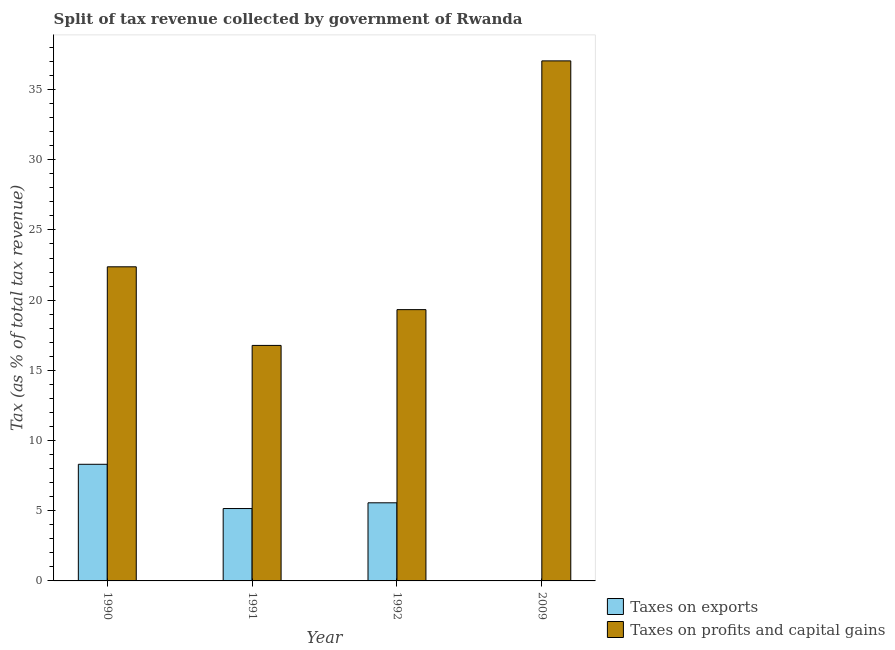How many different coloured bars are there?
Your response must be concise. 2. Are the number of bars per tick equal to the number of legend labels?
Ensure brevity in your answer.  Yes. Are the number of bars on each tick of the X-axis equal?
Your answer should be very brief. Yes. How many bars are there on the 3rd tick from the left?
Give a very brief answer. 2. How many bars are there on the 2nd tick from the right?
Keep it short and to the point. 2. In how many cases, is the number of bars for a given year not equal to the number of legend labels?
Your answer should be compact. 0. What is the percentage of revenue obtained from taxes on exports in 2009?
Ensure brevity in your answer.  0. Across all years, what is the maximum percentage of revenue obtained from taxes on profits and capital gains?
Your answer should be very brief. 37.04. Across all years, what is the minimum percentage of revenue obtained from taxes on exports?
Make the answer very short. 0. In which year was the percentage of revenue obtained from taxes on exports maximum?
Your response must be concise. 1990. What is the total percentage of revenue obtained from taxes on exports in the graph?
Your answer should be very brief. 19.03. What is the difference between the percentage of revenue obtained from taxes on exports in 1991 and that in 2009?
Your answer should be very brief. 5.15. What is the difference between the percentage of revenue obtained from taxes on exports in 1990 and the percentage of revenue obtained from taxes on profits and capital gains in 2009?
Keep it short and to the point. 8.3. What is the average percentage of revenue obtained from taxes on exports per year?
Provide a short and direct response. 4.76. In the year 1990, what is the difference between the percentage of revenue obtained from taxes on profits and capital gains and percentage of revenue obtained from taxes on exports?
Provide a short and direct response. 0. In how many years, is the percentage of revenue obtained from taxes on profits and capital gains greater than 30 %?
Offer a very short reply. 1. What is the ratio of the percentage of revenue obtained from taxes on exports in 1990 to that in 1992?
Provide a succinct answer. 1.49. What is the difference between the highest and the second highest percentage of revenue obtained from taxes on exports?
Your response must be concise. 2.74. What is the difference between the highest and the lowest percentage of revenue obtained from taxes on profits and capital gains?
Provide a succinct answer. 20.27. Is the sum of the percentage of revenue obtained from taxes on exports in 1990 and 2009 greater than the maximum percentage of revenue obtained from taxes on profits and capital gains across all years?
Your answer should be compact. Yes. What does the 1st bar from the left in 1990 represents?
Your answer should be compact. Taxes on exports. What does the 1st bar from the right in 2009 represents?
Offer a terse response. Taxes on profits and capital gains. How many bars are there?
Ensure brevity in your answer.  8. Are all the bars in the graph horizontal?
Your answer should be compact. No. How many years are there in the graph?
Give a very brief answer. 4. What is the difference between two consecutive major ticks on the Y-axis?
Ensure brevity in your answer.  5. Are the values on the major ticks of Y-axis written in scientific E-notation?
Make the answer very short. No. Does the graph contain grids?
Make the answer very short. No. Where does the legend appear in the graph?
Make the answer very short. Bottom right. How many legend labels are there?
Offer a terse response. 2. How are the legend labels stacked?
Offer a very short reply. Vertical. What is the title of the graph?
Provide a succinct answer. Split of tax revenue collected by government of Rwanda. Does "Investment in Telecom" appear as one of the legend labels in the graph?
Your answer should be compact. No. What is the label or title of the Y-axis?
Provide a succinct answer. Tax (as % of total tax revenue). What is the Tax (as % of total tax revenue) in Taxes on exports in 1990?
Your answer should be very brief. 8.31. What is the Tax (as % of total tax revenue) of Taxes on profits and capital gains in 1990?
Give a very brief answer. 22.38. What is the Tax (as % of total tax revenue) of Taxes on exports in 1991?
Offer a terse response. 5.16. What is the Tax (as % of total tax revenue) in Taxes on profits and capital gains in 1991?
Keep it short and to the point. 16.78. What is the Tax (as % of total tax revenue) in Taxes on exports in 1992?
Provide a short and direct response. 5.56. What is the Tax (as % of total tax revenue) of Taxes on profits and capital gains in 1992?
Offer a very short reply. 19.32. What is the Tax (as % of total tax revenue) of Taxes on exports in 2009?
Make the answer very short. 0. What is the Tax (as % of total tax revenue) in Taxes on profits and capital gains in 2009?
Your answer should be very brief. 37.04. Across all years, what is the maximum Tax (as % of total tax revenue) of Taxes on exports?
Offer a terse response. 8.31. Across all years, what is the maximum Tax (as % of total tax revenue) of Taxes on profits and capital gains?
Provide a succinct answer. 37.04. Across all years, what is the minimum Tax (as % of total tax revenue) in Taxes on exports?
Keep it short and to the point. 0. Across all years, what is the minimum Tax (as % of total tax revenue) of Taxes on profits and capital gains?
Keep it short and to the point. 16.78. What is the total Tax (as % of total tax revenue) of Taxes on exports in the graph?
Keep it short and to the point. 19.03. What is the total Tax (as % of total tax revenue) of Taxes on profits and capital gains in the graph?
Offer a very short reply. 95.52. What is the difference between the Tax (as % of total tax revenue) of Taxes on exports in 1990 and that in 1991?
Provide a succinct answer. 3.15. What is the difference between the Tax (as % of total tax revenue) in Taxes on profits and capital gains in 1990 and that in 1991?
Offer a terse response. 5.6. What is the difference between the Tax (as % of total tax revenue) of Taxes on exports in 1990 and that in 1992?
Keep it short and to the point. 2.74. What is the difference between the Tax (as % of total tax revenue) in Taxes on profits and capital gains in 1990 and that in 1992?
Give a very brief answer. 3.05. What is the difference between the Tax (as % of total tax revenue) of Taxes on exports in 1990 and that in 2009?
Your response must be concise. 8.3. What is the difference between the Tax (as % of total tax revenue) of Taxes on profits and capital gains in 1990 and that in 2009?
Provide a short and direct response. -14.67. What is the difference between the Tax (as % of total tax revenue) of Taxes on exports in 1991 and that in 1992?
Provide a succinct answer. -0.41. What is the difference between the Tax (as % of total tax revenue) in Taxes on profits and capital gains in 1991 and that in 1992?
Your answer should be compact. -2.55. What is the difference between the Tax (as % of total tax revenue) in Taxes on exports in 1991 and that in 2009?
Ensure brevity in your answer.  5.15. What is the difference between the Tax (as % of total tax revenue) in Taxes on profits and capital gains in 1991 and that in 2009?
Your answer should be very brief. -20.27. What is the difference between the Tax (as % of total tax revenue) of Taxes on exports in 1992 and that in 2009?
Offer a very short reply. 5.56. What is the difference between the Tax (as % of total tax revenue) of Taxes on profits and capital gains in 1992 and that in 2009?
Offer a terse response. -17.72. What is the difference between the Tax (as % of total tax revenue) in Taxes on exports in 1990 and the Tax (as % of total tax revenue) in Taxes on profits and capital gains in 1991?
Offer a very short reply. -8.47. What is the difference between the Tax (as % of total tax revenue) in Taxes on exports in 1990 and the Tax (as % of total tax revenue) in Taxes on profits and capital gains in 1992?
Your answer should be very brief. -11.02. What is the difference between the Tax (as % of total tax revenue) in Taxes on exports in 1990 and the Tax (as % of total tax revenue) in Taxes on profits and capital gains in 2009?
Your answer should be compact. -28.74. What is the difference between the Tax (as % of total tax revenue) of Taxes on exports in 1991 and the Tax (as % of total tax revenue) of Taxes on profits and capital gains in 1992?
Make the answer very short. -14.17. What is the difference between the Tax (as % of total tax revenue) in Taxes on exports in 1991 and the Tax (as % of total tax revenue) in Taxes on profits and capital gains in 2009?
Offer a terse response. -31.89. What is the difference between the Tax (as % of total tax revenue) of Taxes on exports in 1992 and the Tax (as % of total tax revenue) of Taxes on profits and capital gains in 2009?
Give a very brief answer. -31.48. What is the average Tax (as % of total tax revenue) in Taxes on exports per year?
Make the answer very short. 4.76. What is the average Tax (as % of total tax revenue) in Taxes on profits and capital gains per year?
Keep it short and to the point. 23.88. In the year 1990, what is the difference between the Tax (as % of total tax revenue) in Taxes on exports and Tax (as % of total tax revenue) in Taxes on profits and capital gains?
Your answer should be very brief. -14.07. In the year 1991, what is the difference between the Tax (as % of total tax revenue) of Taxes on exports and Tax (as % of total tax revenue) of Taxes on profits and capital gains?
Your answer should be compact. -11.62. In the year 1992, what is the difference between the Tax (as % of total tax revenue) in Taxes on exports and Tax (as % of total tax revenue) in Taxes on profits and capital gains?
Your response must be concise. -13.76. In the year 2009, what is the difference between the Tax (as % of total tax revenue) of Taxes on exports and Tax (as % of total tax revenue) of Taxes on profits and capital gains?
Offer a very short reply. -37.04. What is the ratio of the Tax (as % of total tax revenue) in Taxes on exports in 1990 to that in 1991?
Your response must be concise. 1.61. What is the ratio of the Tax (as % of total tax revenue) of Taxes on profits and capital gains in 1990 to that in 1991?
Make the answer very short. 1.33. What is the ratio of the Tax (as % of total tax revenue) in Taxes on exports in 1990 to that in 1992?
Offer a terse response. 1.49. What is the ratio of the Tax (as % of total tax revenue) of Taxes on profits and capital gains in 1990 to that in 1992?
Give a very brief answer. 1.16. What is the ratio of the Tax (as % of total tax revenue) of Taxes on exports in 1990 to that in 2009?
Give a very brief answer. 1754.5. What is the ratio of the Tax (as % of total tax revenue) in Taxes on profits and capital gains in 1990 to that in 2009?
Offer a terse response. 0.6. What is the ratio of the Tax (as % of total tax revenue) in Taxes on exports in 1991 to that in 1992?
Provide a succinct answer. 0.93. What is the ratio of the Tax (as % of total tax revenue) of Taxes on profits and capital gains in 1991 to that in 1992?
Make the answer very short. 0.87. What is the ratio of the Tax (as % of total tax revenue) in Taxes on exports in 1991 to that in 2009?
Provide a short and direct response. 1088.75. What is the ratio of the Tax (as % of total tax revenue) of Taxes on profits and capital gains in 1991 to that in 2009?
Offer a terse response. 0.45. What is the ratio of the Tax (as % of total tax revenue) of Taxes on exports in 1992 to that in 2009?
Provide a short and direct response. 1175.04. What is the ratio of the Tax (as % of total tax revenue) in Taxes on profits and capital gains in 1992 to that in 2009?
Offer a very short reply. 0.52. What is the difference between the highest and the second highest Tax (as % of total tax revenue) in Taxes on exports?
Your answer should be compact. 2.74. What is the difference between the highest and the second highest Tax (as % of total tax revenue) in Taxes on profits and capital gains?
Offer a terse response. 14.67. What is the difference between the highest and the lowest Tax (as % of total tax revenue) in Taxes on exports?
Make the answer very short. 8.3. What is the difference between the highest and the lowest Tax (as % of total tax revenue) of Taxes on profits and capital gains?
Your answer should be very brief. 20.27. 